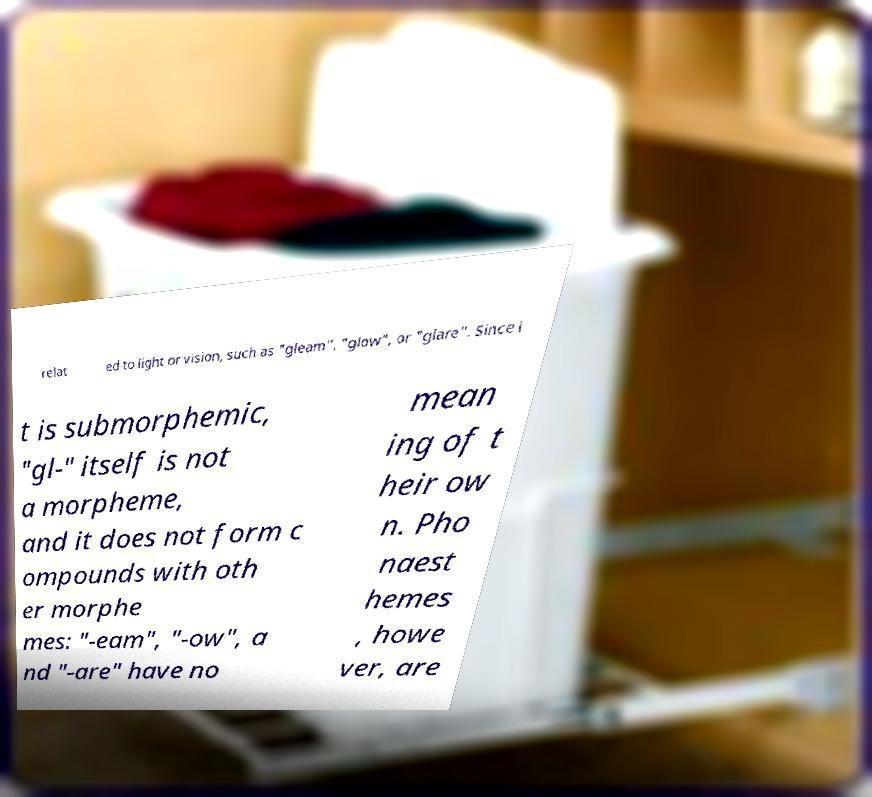I need the written content from this picture converted into text. Can you do that? relat ed to light or vision, such as "gleam", "glow", or "glare". Since i t is submorphemic, "gl-" itself is not a morpheme, and it does not form c ompounds with oth er morphe mes: "-eam", "-ow", a nd "-are" have no mean ing of t heir ow n. Pho naest hemes , howe ver, are 